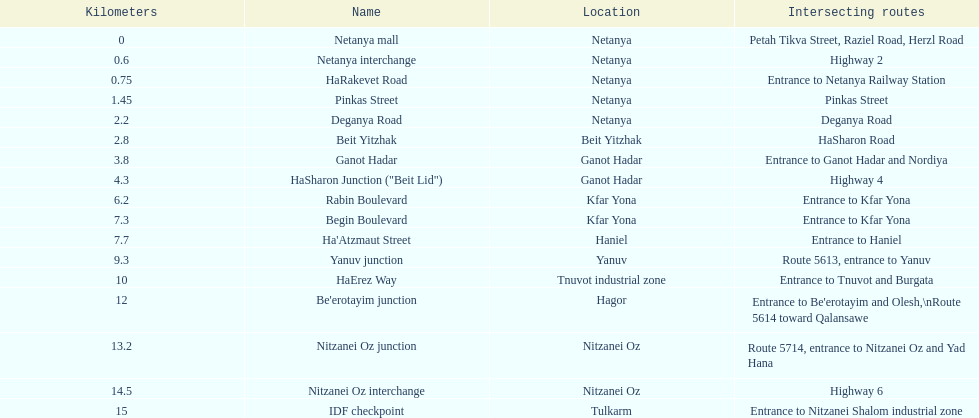Upon finishing deganya road, which section follows? Beit Yitzhak. 